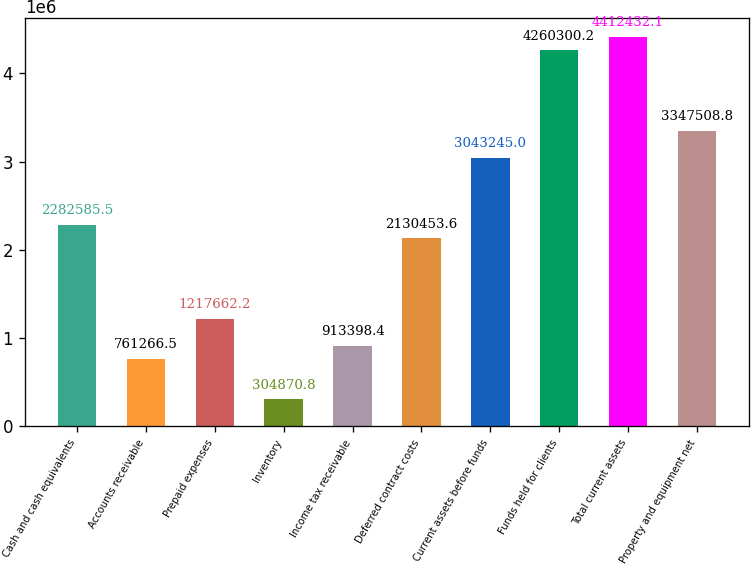<chart> <loc_0><loc_0><loc_500><loc_500><bar_chart><fcel>Cash and cash equivalents<fcel>Accounts receivable<fcel>Prepaid expenses<fcel>Inventory<fcel>Income tax receivable<fcel>Deferred contract costs<fcel>Current assets before funds<fcel>Funds held for clients<fcel>Total current assets<fcel>Property and equipment net<nl><fcel>2.28259e+06<fcel>761266<fcel>1.21766e+06<fcel>304871<fcel>913398<fcel>2.13045e+06<fcel>3.04324e+06<fcel>4.2603e+06<fcel>4.41243e+06<fcel>3.34751e+06<nl></chart> 